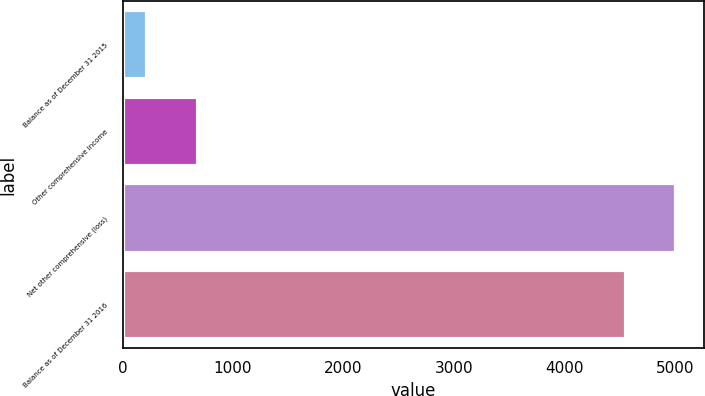Convert chart. <chart><loc_0><loc_0><loc_500><loc_500><bar_chart><fcel>Balance as of December 31 2015<fcel>Other comprehensive income<fcel>Net other comprehensive (loss)<fcel>Balance as of December 31 2016<nl><fcel>224<fcel>679.6<fcel>5011.6<fcel>4556<nl></chart> 